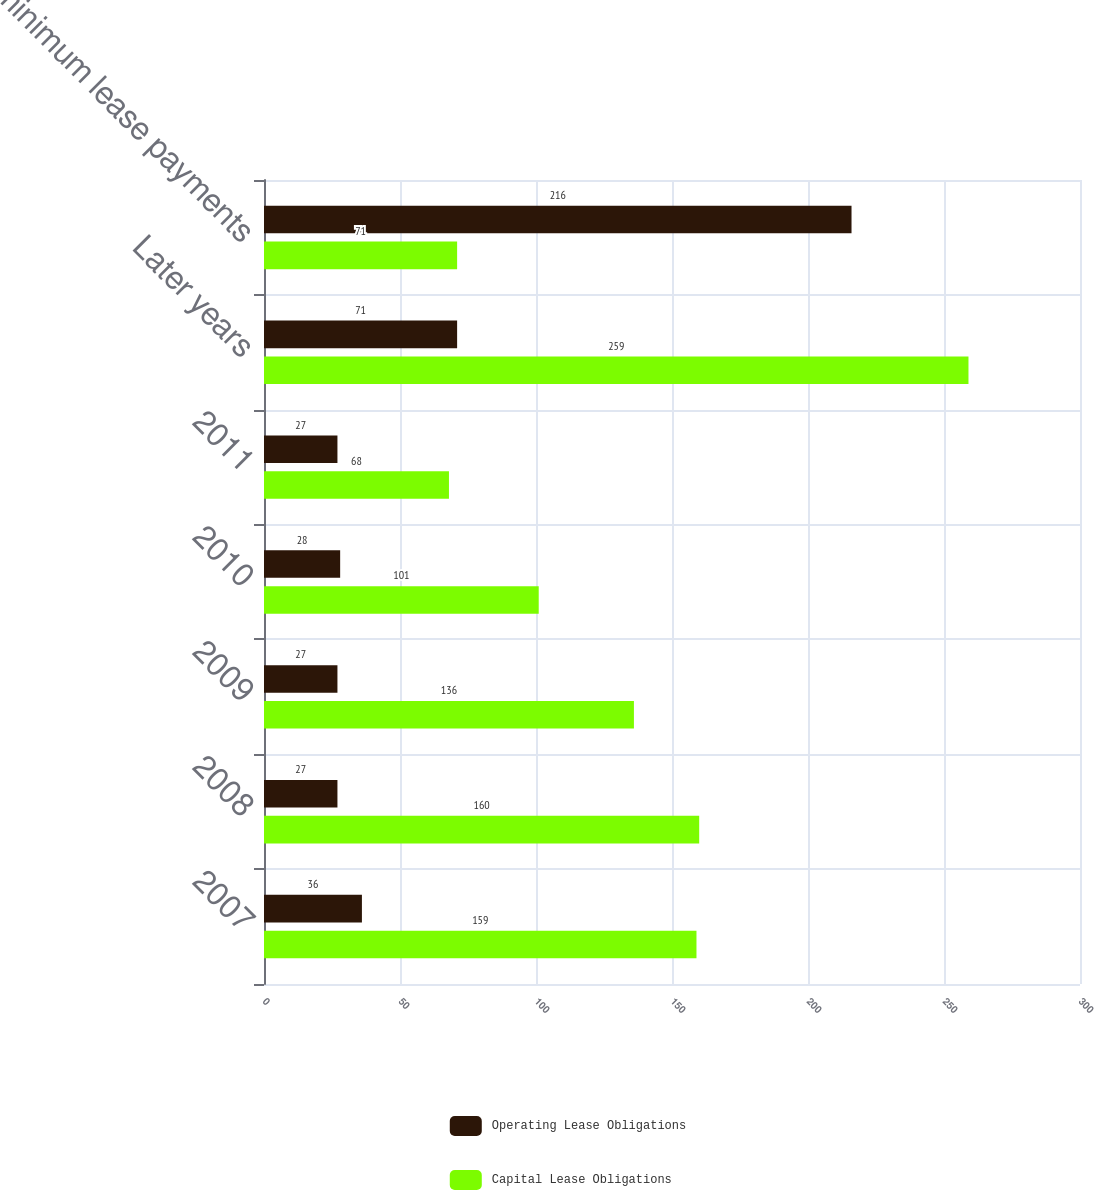<chart> <loc_0><loc_0><loc_500><loc_500><stacked_bar_chart><ecel><fcel>2007<fcel>2008<fcel>2009<fcel>2010<fcel>2011<fcel>Later years<fcel>Total minimum lease payments<nl><fcel>Operating Lease Obligations<fcel>36<fcel>27<fcel>27<fcel>28<fcel>27<fcel>71<fcel>216<nl><fcel>Capital Lease Obligations<fcel>159<fcel>160<fcel>136<fcel>101<fcel>68<fcel>259<fcel>71<nl></chart> 